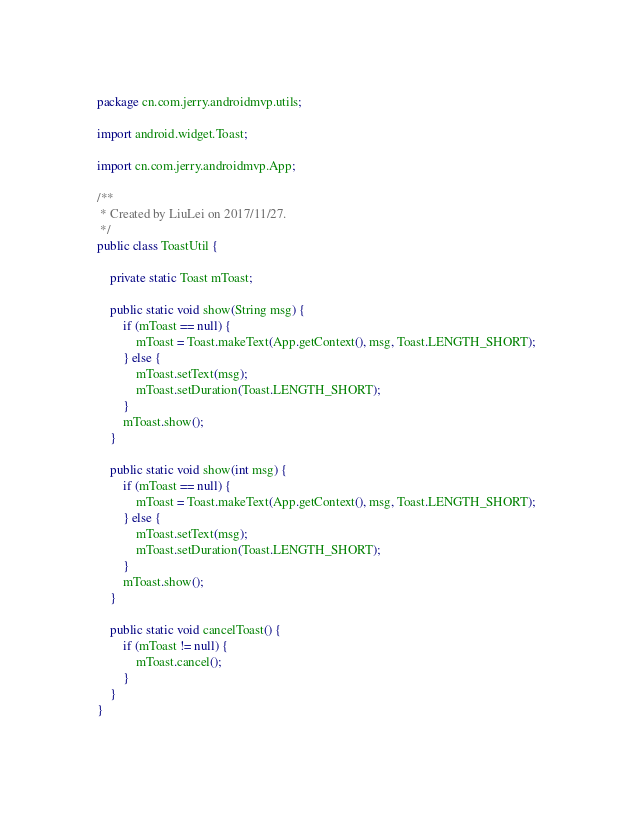<code> <loc_0><loc_0><loc_500><loc_500><_Java_>package cn.com.jerry.androidmvp.utils;

import android.widget.Toast;

import cn.com.jerry.androidmvp.App;

/**
 * Created by LiuLei on 2017/11/27.
 */
public class ToastUtil {

    private static Toast mToast;

    public static void show(String msg) {
        if (mToast == null) {
            mToast = Toast.makeText(App.getContext(), msg, Toast.LENGTH_SHORT);
        } else {
            mToast.setText(msg);
            mToast.setDuration(Toast.LENGTH_SHORT);
        }
        mToast.show();
    }

    public static void show(int msg) {
        if (mToast == null) {
            mToast = Toast.makeText(App.getContext(), msg, Toast.LENGTH_SHORT);
        } else {
            mToast.setText(msg);
            mToast.setDuration(Toast.LENGTH_SHORT);
        }
        mToast.show();
    }

    public static void cancelToast() {
        if (mToast != null) {
            mToast.cancel();
        }
    }
}
</code> 